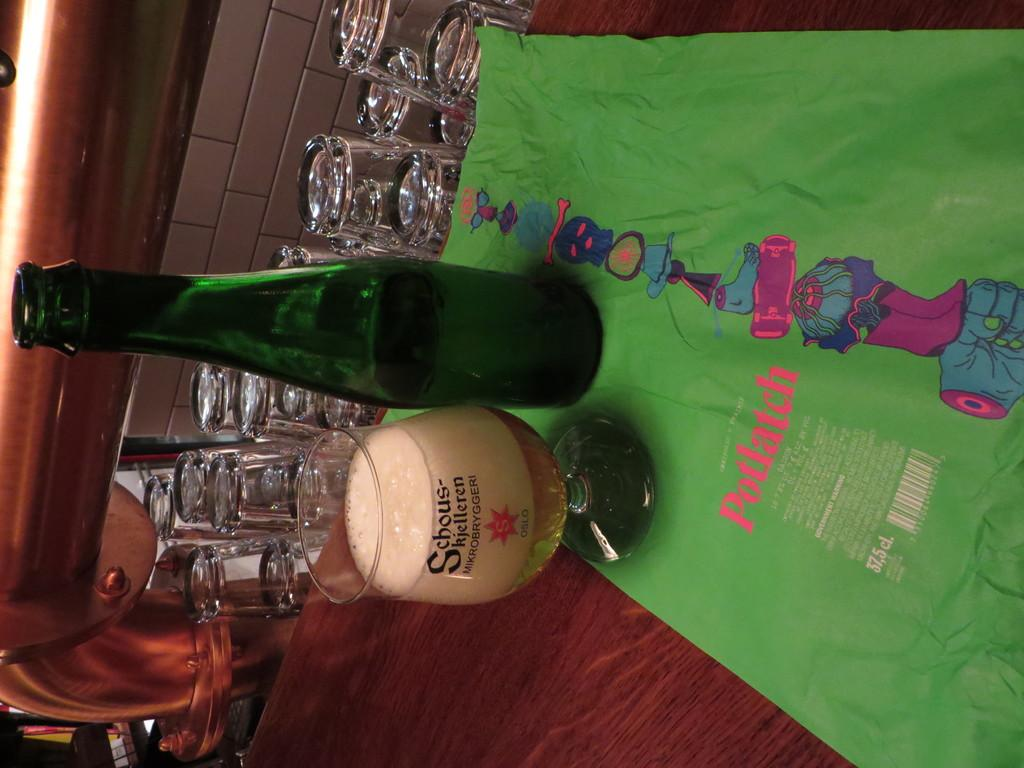<image>
Present a compact description of the photo's key features. green bottle next to full glass with schous-skjelleren mikrobryggeri on a green mat with potlatch on it 